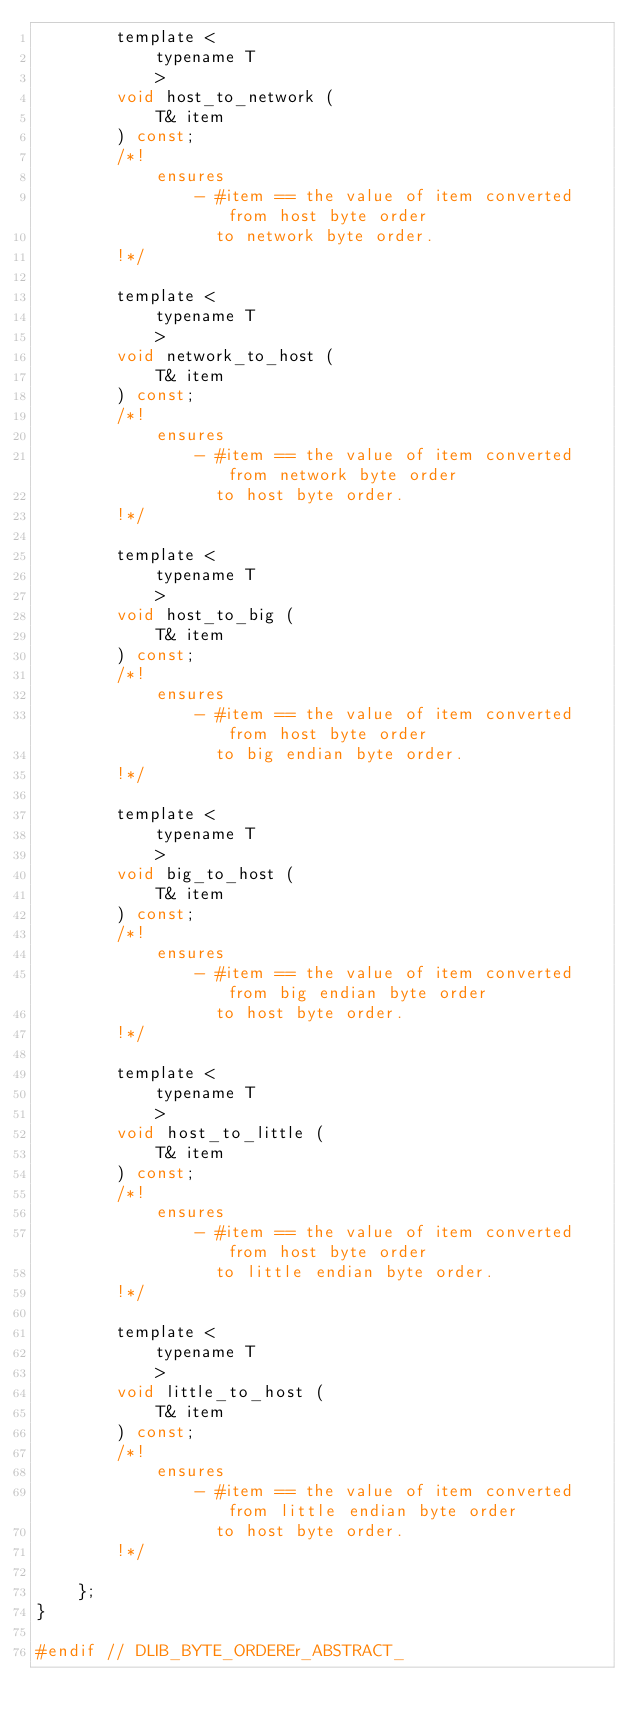Convert code to text. <code><loc_0><loc_0><loc_500><loc_500><_C_>        template <
            typename T
            >
        void host_to_network (
            T& item
        ) const;
        /*!
            ensures
                - #item == the value of item converted from host byte order 
                  to network byte order.
        !*/

        template <
            typename T
            >
        void network_to_host (
            T& item
        ) const;
        /*!
            ensures
                - #item == the value of item converted from network byte order
                  to host byte order.
        !*/

        template <
            typename T
            >
        void host_to_big (
            T& item
        ) const;
        /*!
            ensures
                - #item == the value of item converted from host byte order 
                  to big endian byte order.
        !*/

        template <
            typename T
            >
        void big_to_host (
            T& item
        ) const;
        /*!
            ensures
                - #item == the value of item converted from big endian byte order
                  to host byte order.
        !*/

        template <
            typename T
            >
        void host_to_little (
            T& item
        ) const;
        /*!
            ensures
                - #item == the value of item converted from host byte order 
                  to little endian byte order.
        !*/

        template <
            typename T
            >
        void little_to_host (
            T& item
        ) const;
        /*!
            ensures
                - #item == the value of item converted from little endian byte order
                  to host byte order.
        !*/

    };    
}

#endif // DLIB_BYTE_ORDEREr_ABSTRACT_ 

</code> 